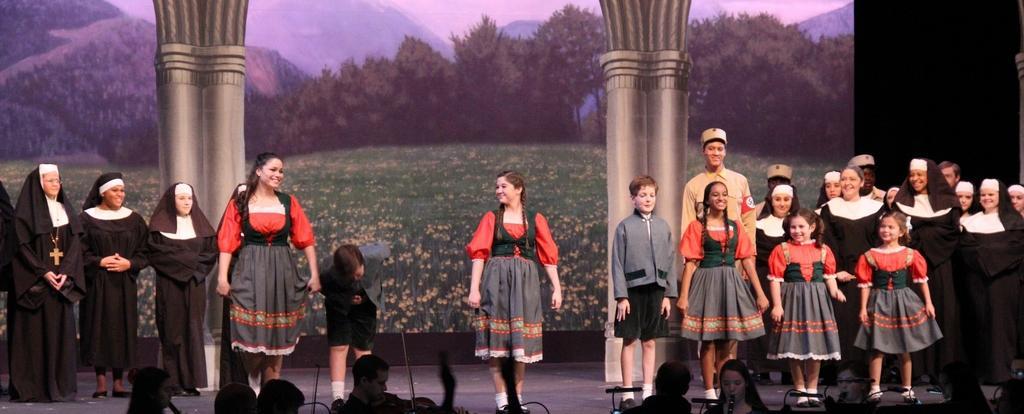Please provide a concise description of this image. In this image there are group of people and some children who are standing on a stage, and in the background there is a board. On the board there are some trees, mountains and grass and pillars. At the bottom there are some people who are holding some musical instruments and playing, and on the right side of the image there is black background. 